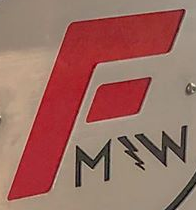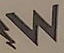Read the text content from these images in order, separated by a semicolon. F; W 